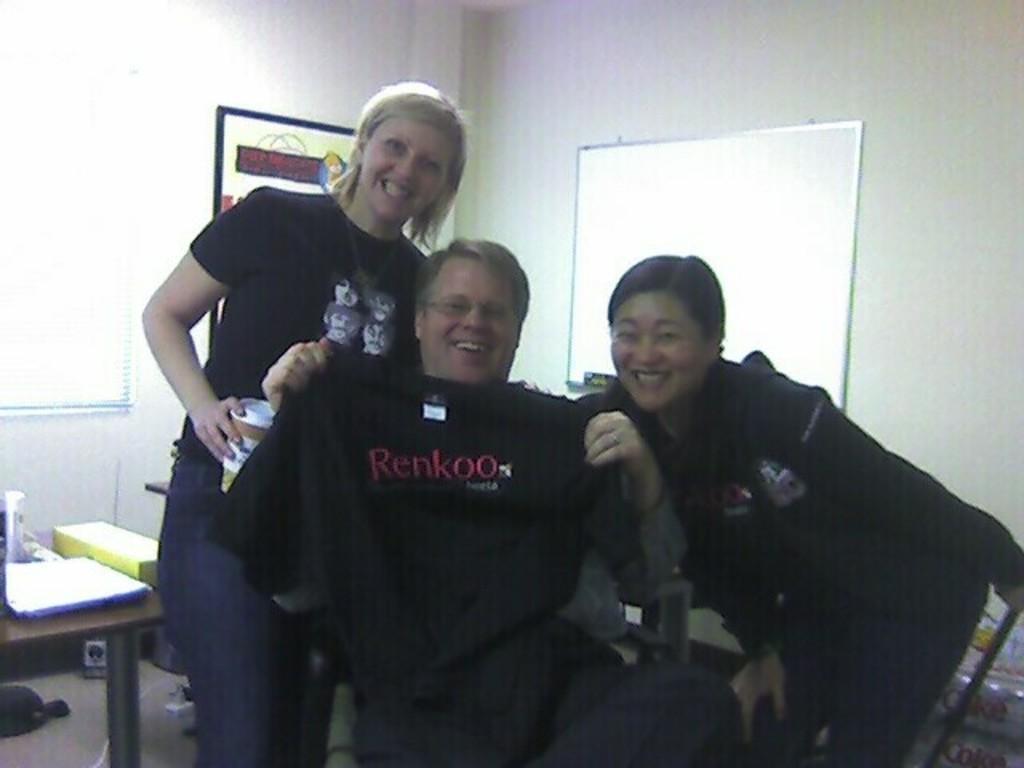Could you give a brief overview of what you see in this image? In this picture we can see a woman is standing she is smiling she is wearing a black color t-shirt and she is holding a tin in her hand ,and here is the man sitting on a chair he is smiling, and beside him a woman is smiling and here is the wall, and there is the table and some papers on it, here is the floor. 